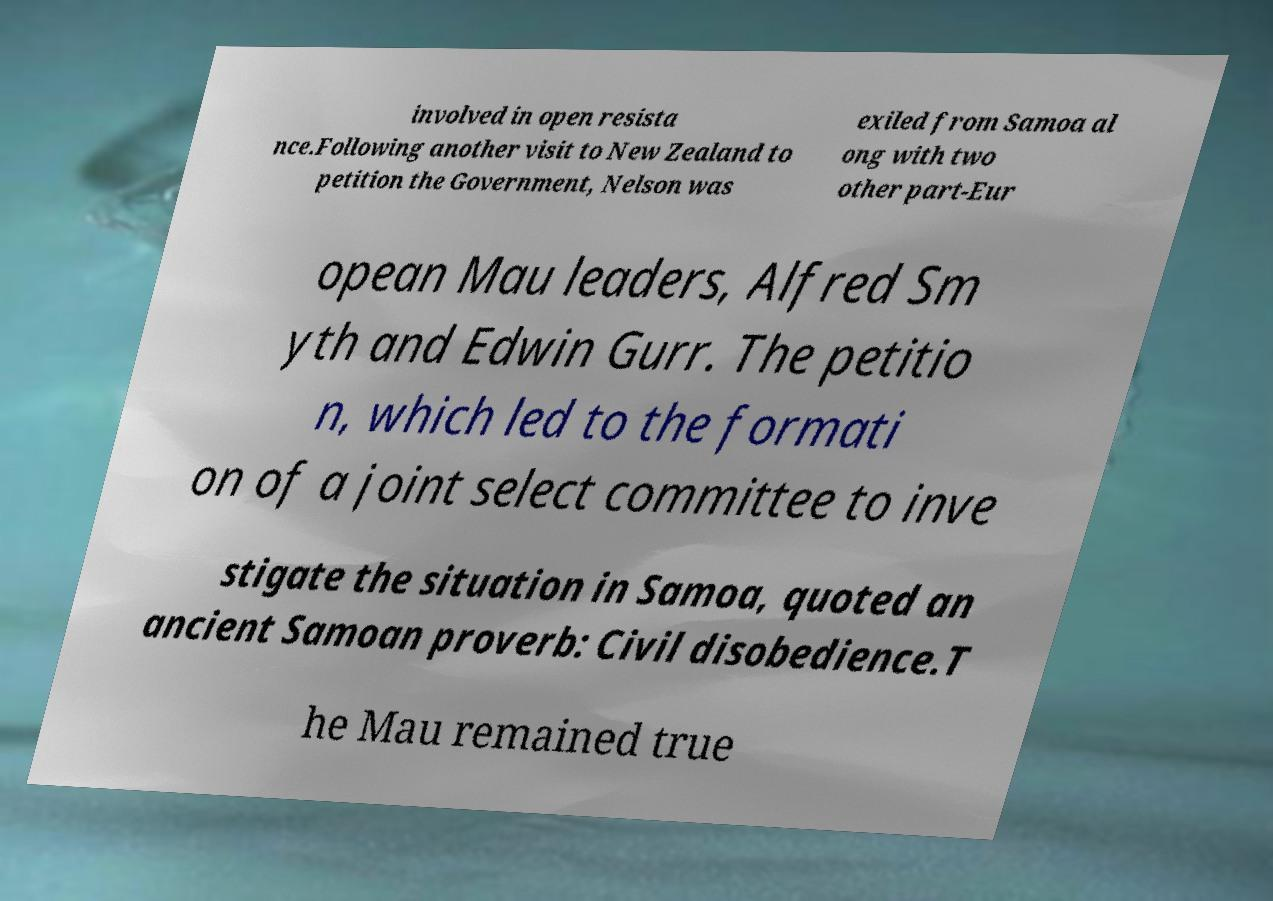Can you accurately transcribe the text from the provided image for me? involved in open resista nce.Following another visit to New Zealand to petition the Government, Nelson was exiled from Samoa al ong with two other part-Eur opean Mau leaders, Alfred Sm yth and Edwin Gurr. The petitio n, which led to the formati on of a joint select committee to inve stigate the situation in Samoa, quoted an ancient Samoan proverb: Civil disobedience.T he Mau remained true 